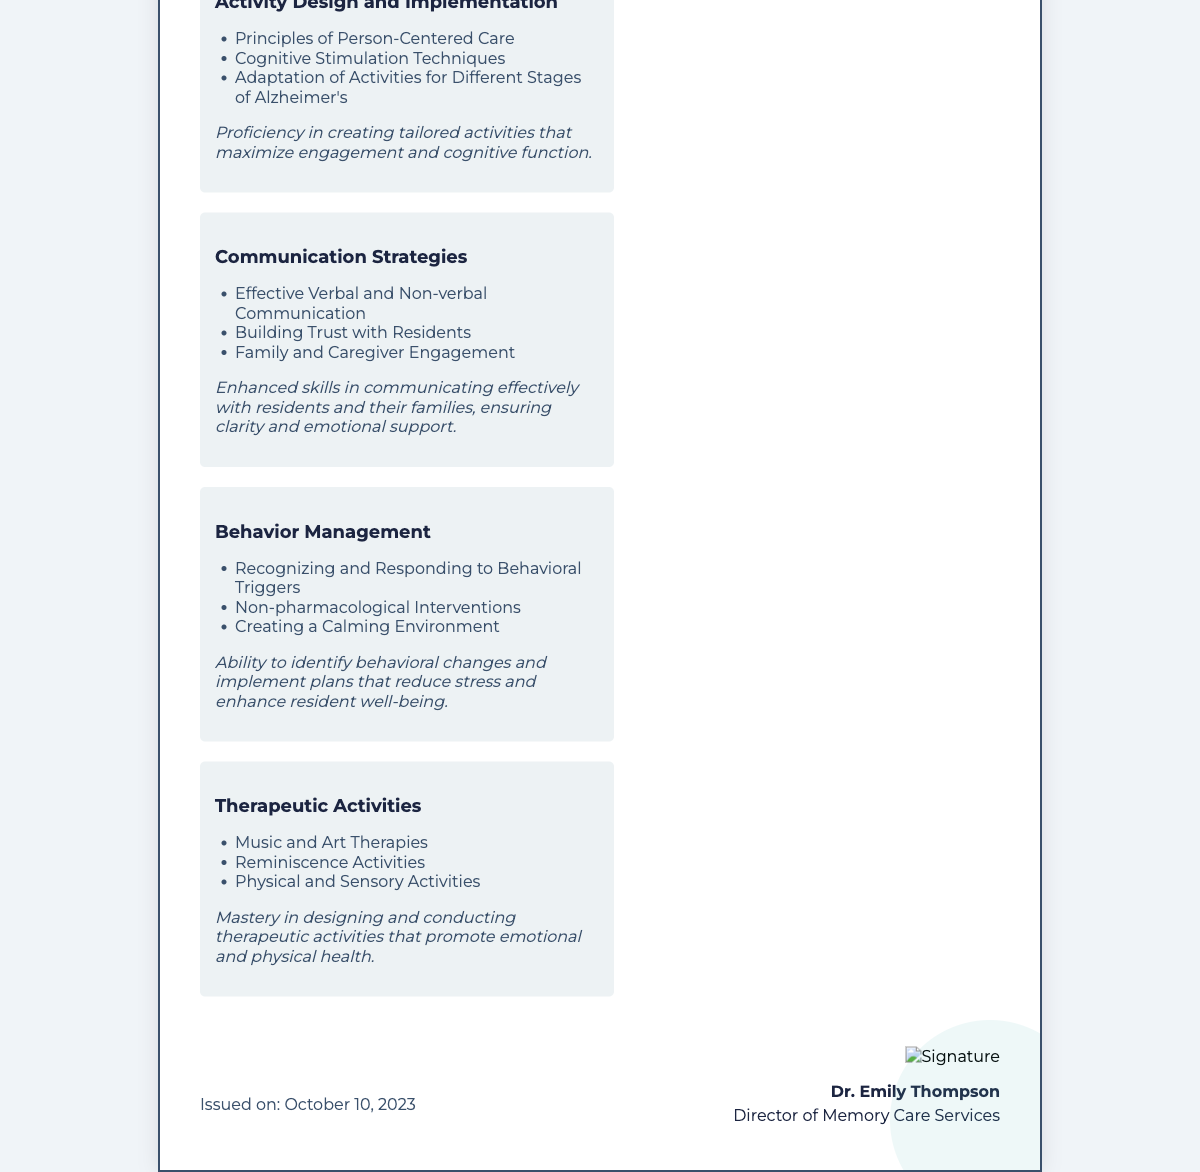What is the name of the recipient? The recipient of the certificate is explicitly named as Jane Doe.
Answer: Jane Doe What is the name of the issuing institute? The institute awarding the certificate is stated as Alzheimer's Nursing Facility.
Answer: Alzheimer's Nursing Facility What is the date the certificate was issued? The document specifies the issuance date as October 10, 2023.
Answer: October 10, 2023 What is the title of the certificate? The title presented at the top of the document describes it as the Certificate of Proficiency in Memory Care Activity Planning.
Answer: Certificate of Proficiency in Memory Care Activity Planning What is one of the components listed under "Activity Design and Implementation"? The document lists several elements under this component; one is Principles of Person-Centered Care.
Answer: Principles of Person-Centered Care What is the primary focus of the certificate? The certificate acknowledges proficiency in planning and executing memory care activities for individuals with Alzheimer's disease.
Answer: Planning and executing memory care activities Who is the signatory of the certificate? The certificate is signed by Dr. Emily Thompson, identified as the Director of Memory Care Services.
Answer: Dr. Emily Thompson What therapeutic activity is included in the document? The document lists Music and Art Therapies as one of the therapeutic activities.
Answer: Music and Art Therapies How many components are detailed in the certificate? The document outlines a total of four components regarding proficiency in memory care activity planning.
Answer: Four 